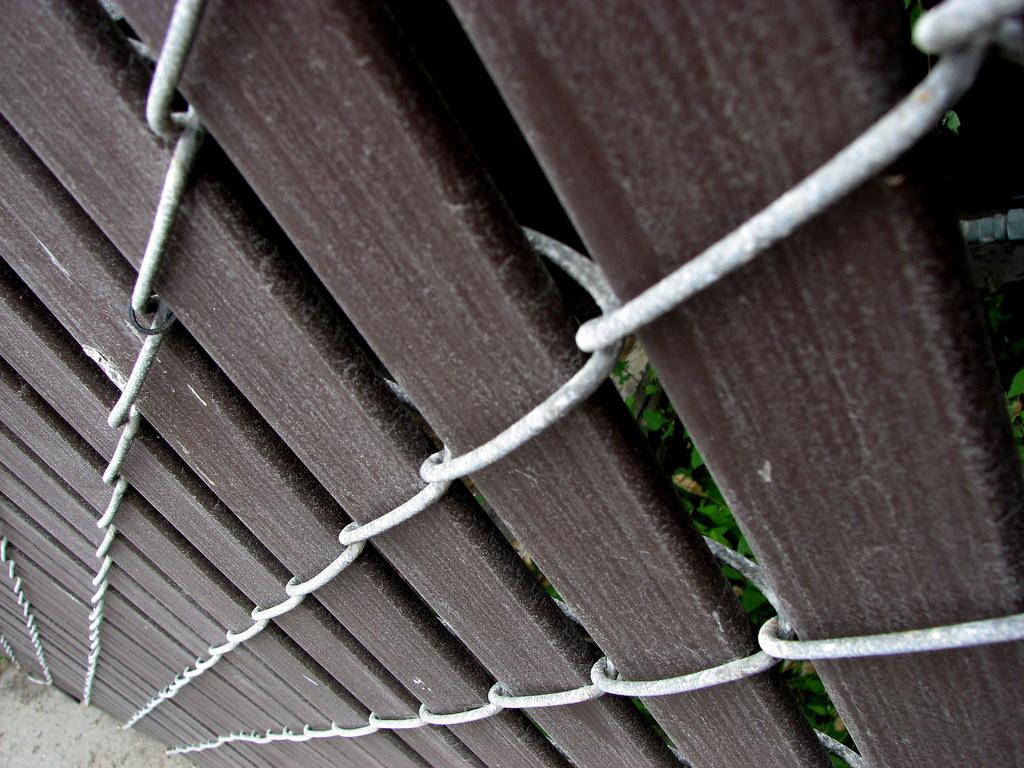What type of material is used to construct the objects in the image? The objects in the image are made of wooden planks. How are the wooden planks connected or held together? The wooden planks are tied with steel wires. What can be seen in the background of the image? Leaves of plants are visible behind the wooden planks. What type of thread is being used by the writer in the image? There is no writer or thread present in the image; it features wooden planks tied with steel wires and leaves of plants in the background. 